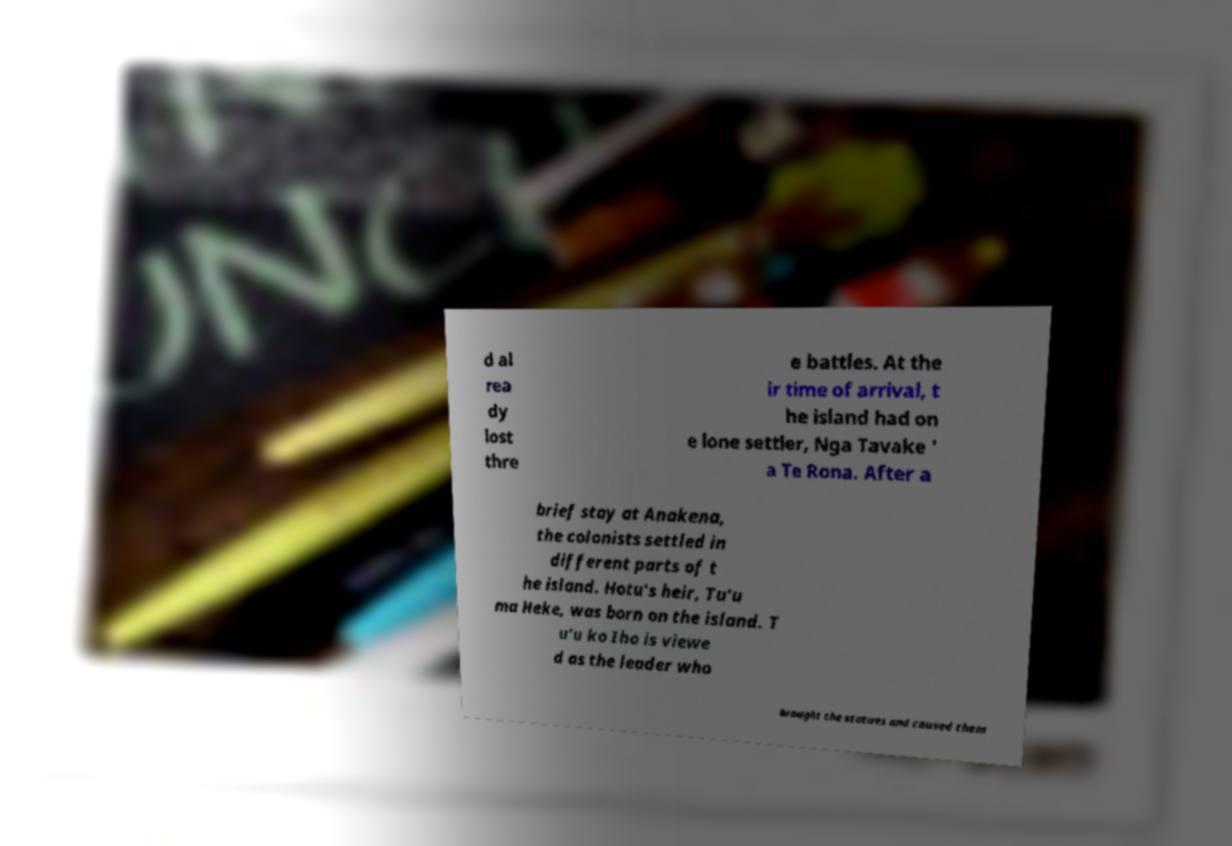What messages or text are displayed in this image? I need them in a readable, typed format. d al rea dy lost thre e battles. At the ir time of arrival, t he island had on e lone settler, Nga Tavake ' a Te Rona. After a brief stay at Anakena, the colonists settled in different parts of t he island. Hotu's heir, Tu'u ma Heke, was born on the island. T u'u ko Iho is viewe d as the leader who brought the statues and caused them 